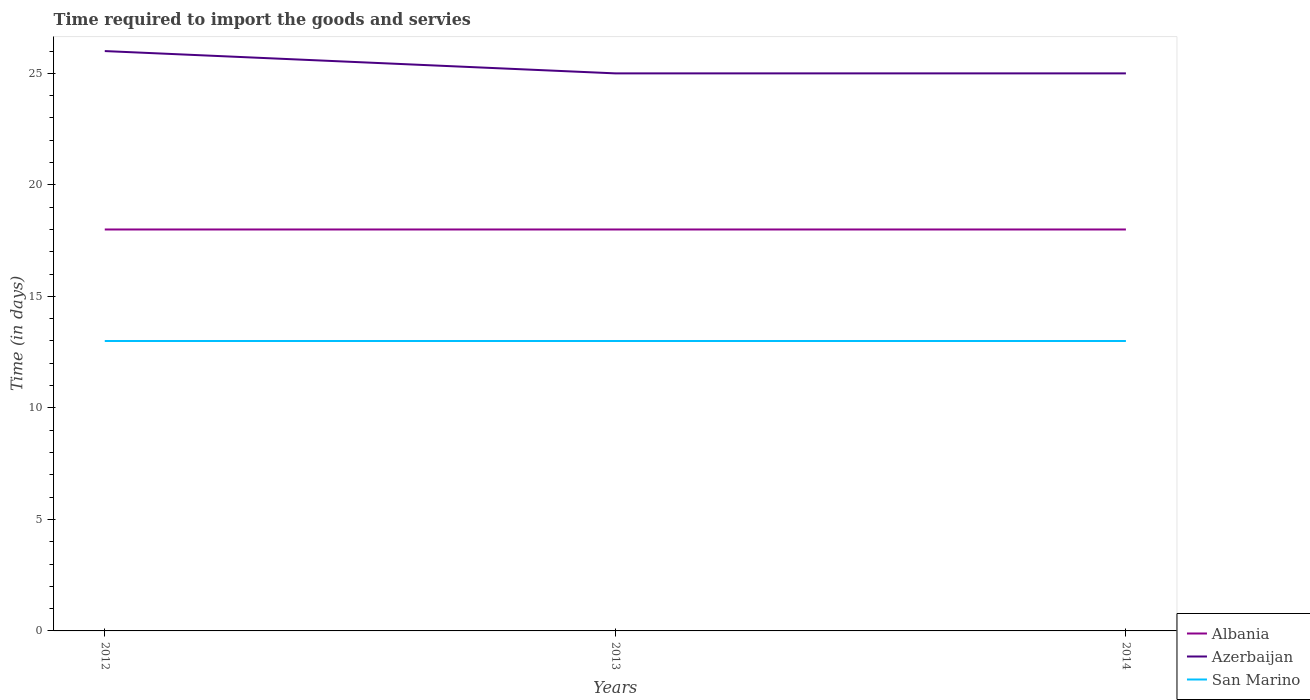How many different coloured lines are there?
Offer a very short reply. 3. Is the number of lines equal to the number of legend labels?
Your answer should be very brief. Yes. Across all years, what is the maximum number of days required to import the goods and services in Azerbaijan?
Provide a short and direct response. 25. What is the total number of days required to import the goods and services in Albania in the graph?
Offer a terse response. 0. What is the difference between the highest and the second highest number of days required to import the goods and services in San Marino?
Provide a short and direct response. 0. What is the difference between the highest and the lowest number of days required to import the goods and services in Azerbaijan?
Your answer should be compact. 1. Is the number of days required to import the goods and services in Albania strictly greater than the number of days required to import the goods and services in Azerbaijan over the years?
Make the answer very short. Yes. How many lines are there?
Your answer should be compact. 3. Does the graph contain any zero values?
Keep it short and to the point. No. How many legend labels are there?
Your answer should be very brief. 3. What is the title of the graph?
Give a very brief answer. Time required to import the goods and servies. Does "Austria" appear as one of the legend labels in the graph?
Your response must be concise. No. What is the label or title of the X-axis?
Provide a succinct answer. Years. What is the label or title of the Y-axis?
Offer a terse response. Time (in days). What is the Time (in days) in Albania in 2012?
Keep it short and to the point. 18. What is the Time (in days) of Azerbaijan in 2012?
Offer a very short reply. 26. What is the Time (in days) in San Marino in 2012?
Give a very brief answer. 13. What is the Time (in days) of Albania in 2013?
Provide a succinct answer. 18. What is the Time (in days) in Azerbaijan in 2013?
Provide a short and direct response. 25. What is the Time (in days) of San Marino in 2013?
Your answer should be compact. 13. What is the Time (in days) in San Marino in 2014?
Your response must be concise. 13. Across all years, what is the maximum Time (in days) of Albania?
Provide a short and direct response. 18. Across all years, what is the maximum Time (in days) in Azerbaijan?
Keep it short and to the point. 26. Across all years, what is the minimum Time (in days) of Azerbaijan?
Provide a succinct answer. 25. What is the difference between the Time (in days) in San Marino in 2012 and that in 2013?
Make the answer very short. 0. What is the difference between the Time (in days) in Albania in 2012 and that in 2014?
Your answer should be compact. 0. What is the difference between the Time (in days) in Azerbaijan in 2012 and that in 2014?
Your response must be concise. 1. What is the difference between the Time (in days) in Azerbaijan in 2013 and that in 2014?
Keep it short and to the point. 0. What is the difference between the Time (in days) in San Marino in 2013 and that in 2014?
Ensure brevity in your answer.  0. What is the difference between the Time (in days) in Albania in 2012 and the Time (in days) in San Marino in 2013?
Make the answer very short. 5. What is the difference between the Time (in days) of Azerbaijan in 2012 and the Time (in days) of San Marino in 2014?
Offer a very short reply. 13. What is the difference between the Time (in days) of Albania in 2013 and the Time (in days) of Azerbaijan in 2014?
Give a very brief answer. -7. What is the difference between the Time (in days) of Albania in 2013 and the Time (in days) of San Marino in 2014?
Offer a very short reply. 5. What is the difference between the Time (in days) in Azerbaijan in 2013 and the Time (in days) in San Marino in 2014?
Offer a terse response. 12. What is the average Time (in days) in Albania per year?
Ensure brevity in your answer.  18. What is the average Time (in days) in Azerbaijan per year?
Your answer should be compact. 25.33. What is the average Time (in days) of San Marino per year?
Your answer should be very brief. 13. In the year 2012, what is the difference between the Time (in days) of Azerbaijan and Time (in days) of San Marino?
Ensure brevity in your answer.  13. In the year 2013, what is the difference between the Time (in days) in Albania and Time (in days) in Azerbaijan?
Make the answer very short. -7. In the year 2014, what is the difference between the Time (in days) of Albania and Time (in days) of San Marino?
Ensure brevity in your answer.  5. In the year 2014, what is the difference between the Time (in days) in Azerbaijan and Time (in days) in San Marino?
Your response must be concise. 12. What is the ratio of the Time (in days) in San Marino in 2012 to that in 2013?
Ensure brevity in your answer.  1. What is the ratio of the Time (in days) of Albania in 2012 to that in 2014?
Keep it short and to the point. 1. What is the ratio of the Time (in days) of Azerbaijan in 2012 to that in 2014?
Provide a succinct answer. 1.04. What is the ratio of the Time (in days) of San Marino in 2012 to that in 2014?
Offer a terse response. 1. What is the ratio of the Time (in days) in Albania in 2013 to that in 2014?
Your answer should be very brief. 1. What is the ratio of the Time (in days) in Azerbaijan in 2013 to that in 2014?
Make the answer very short. 1. What is the ratio of the Time (in days) in San Marino in 2013 to that in 2014?
Give a very brief answer. 1. What is the difference between the highest and the second highest Time (in days) of Azerbaijan?
Your answer should be compact. 1. What is the difference between the highest and the second highest Time (in days) of San Marino?
Provide a succinct answer. 0. What is the difference between the highest and the lowest Time (in days) in Albania?
Keep it short and to the point. 0. What is the difference between the highest and the lowest Time (in days) of Azerbaijan?
Make the answer very short. 1. What is the difference between the highest and the lowest Time (in days) in San Marino?
Your response must be concise. 0. 